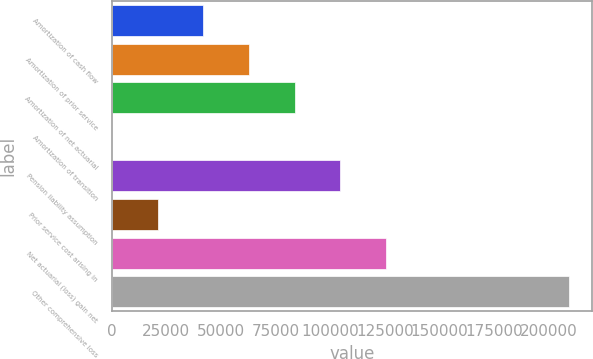Convert chart. <chart><loc_0><loc_0><loc_500><loc_500><bar_chart><fcel>Amortization of cash flow<fcel>Amortization of prior service<fcel>Amortization of net actuarial<fcel>Amortization of transition<fcel>Pension liability assumption<fcel>Prior service cost arising in<fcel>Net actuarial (loss) gain net<fcel>Other comprehensive loss<nl><fcel>41918<fcel>62830.5<fcel>83743<fcel>93<fcel>104656<fcel>21005.5<fcel>125568<fcel>209218<nl></chart> 